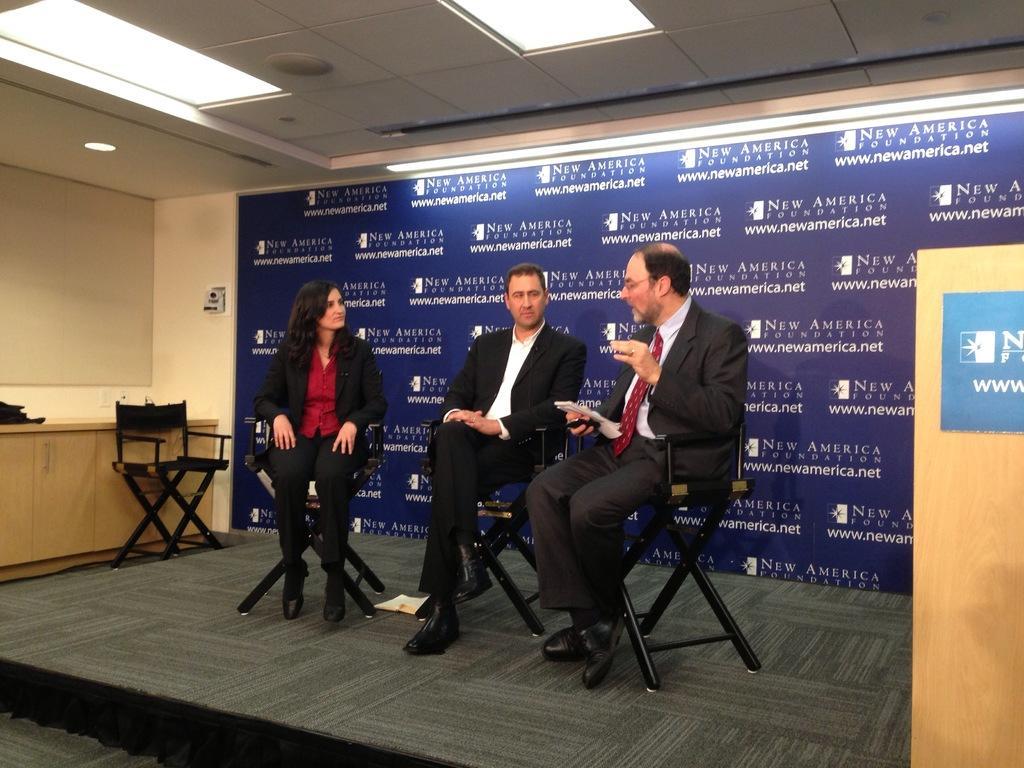In one or two sentences, can you explain what this image depicts? In this image, we can see three persons wearing clothes and sitting on chairs in front of the board. There is a chair on the left side of the image. There are lights on the ceiling which is at the top of the image. 